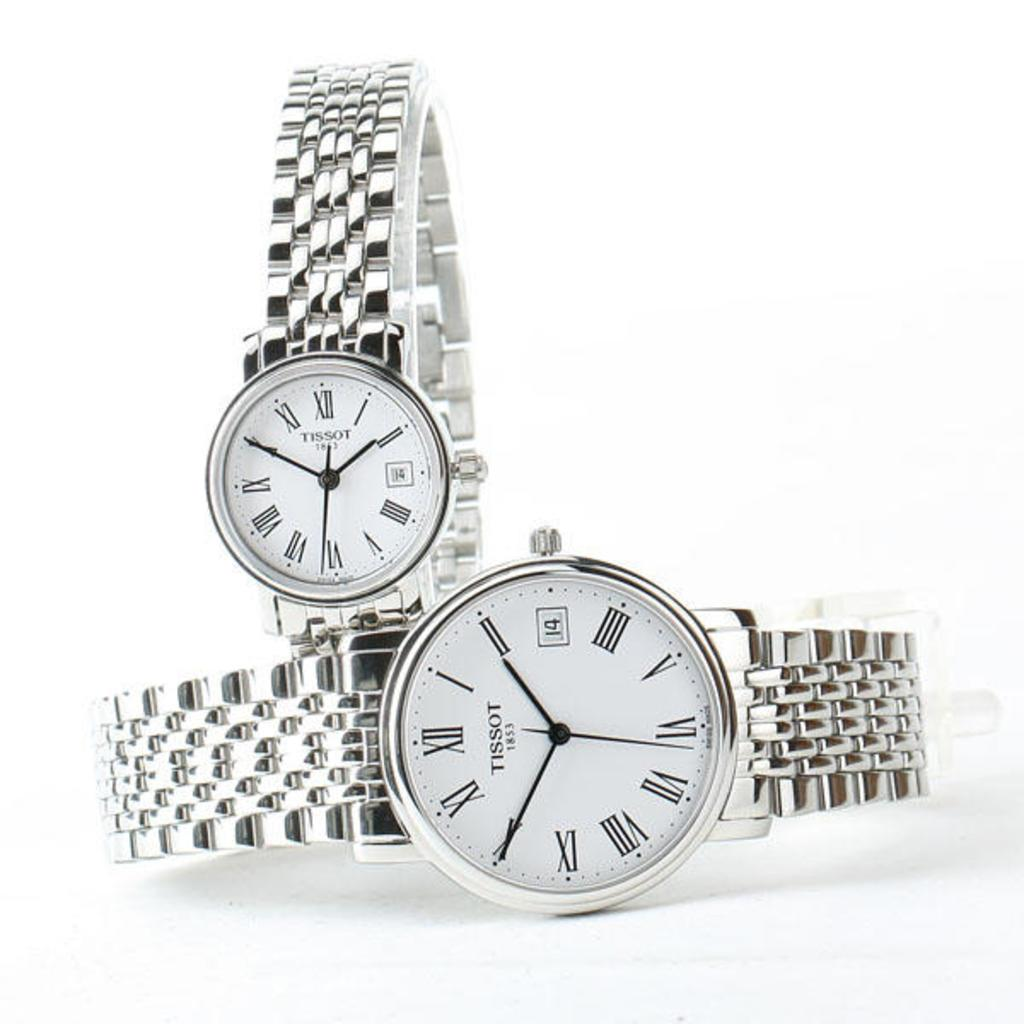<image>
Relay a brief, clear account of the picture shown. a couple of white watches with 1 to 12 on it 